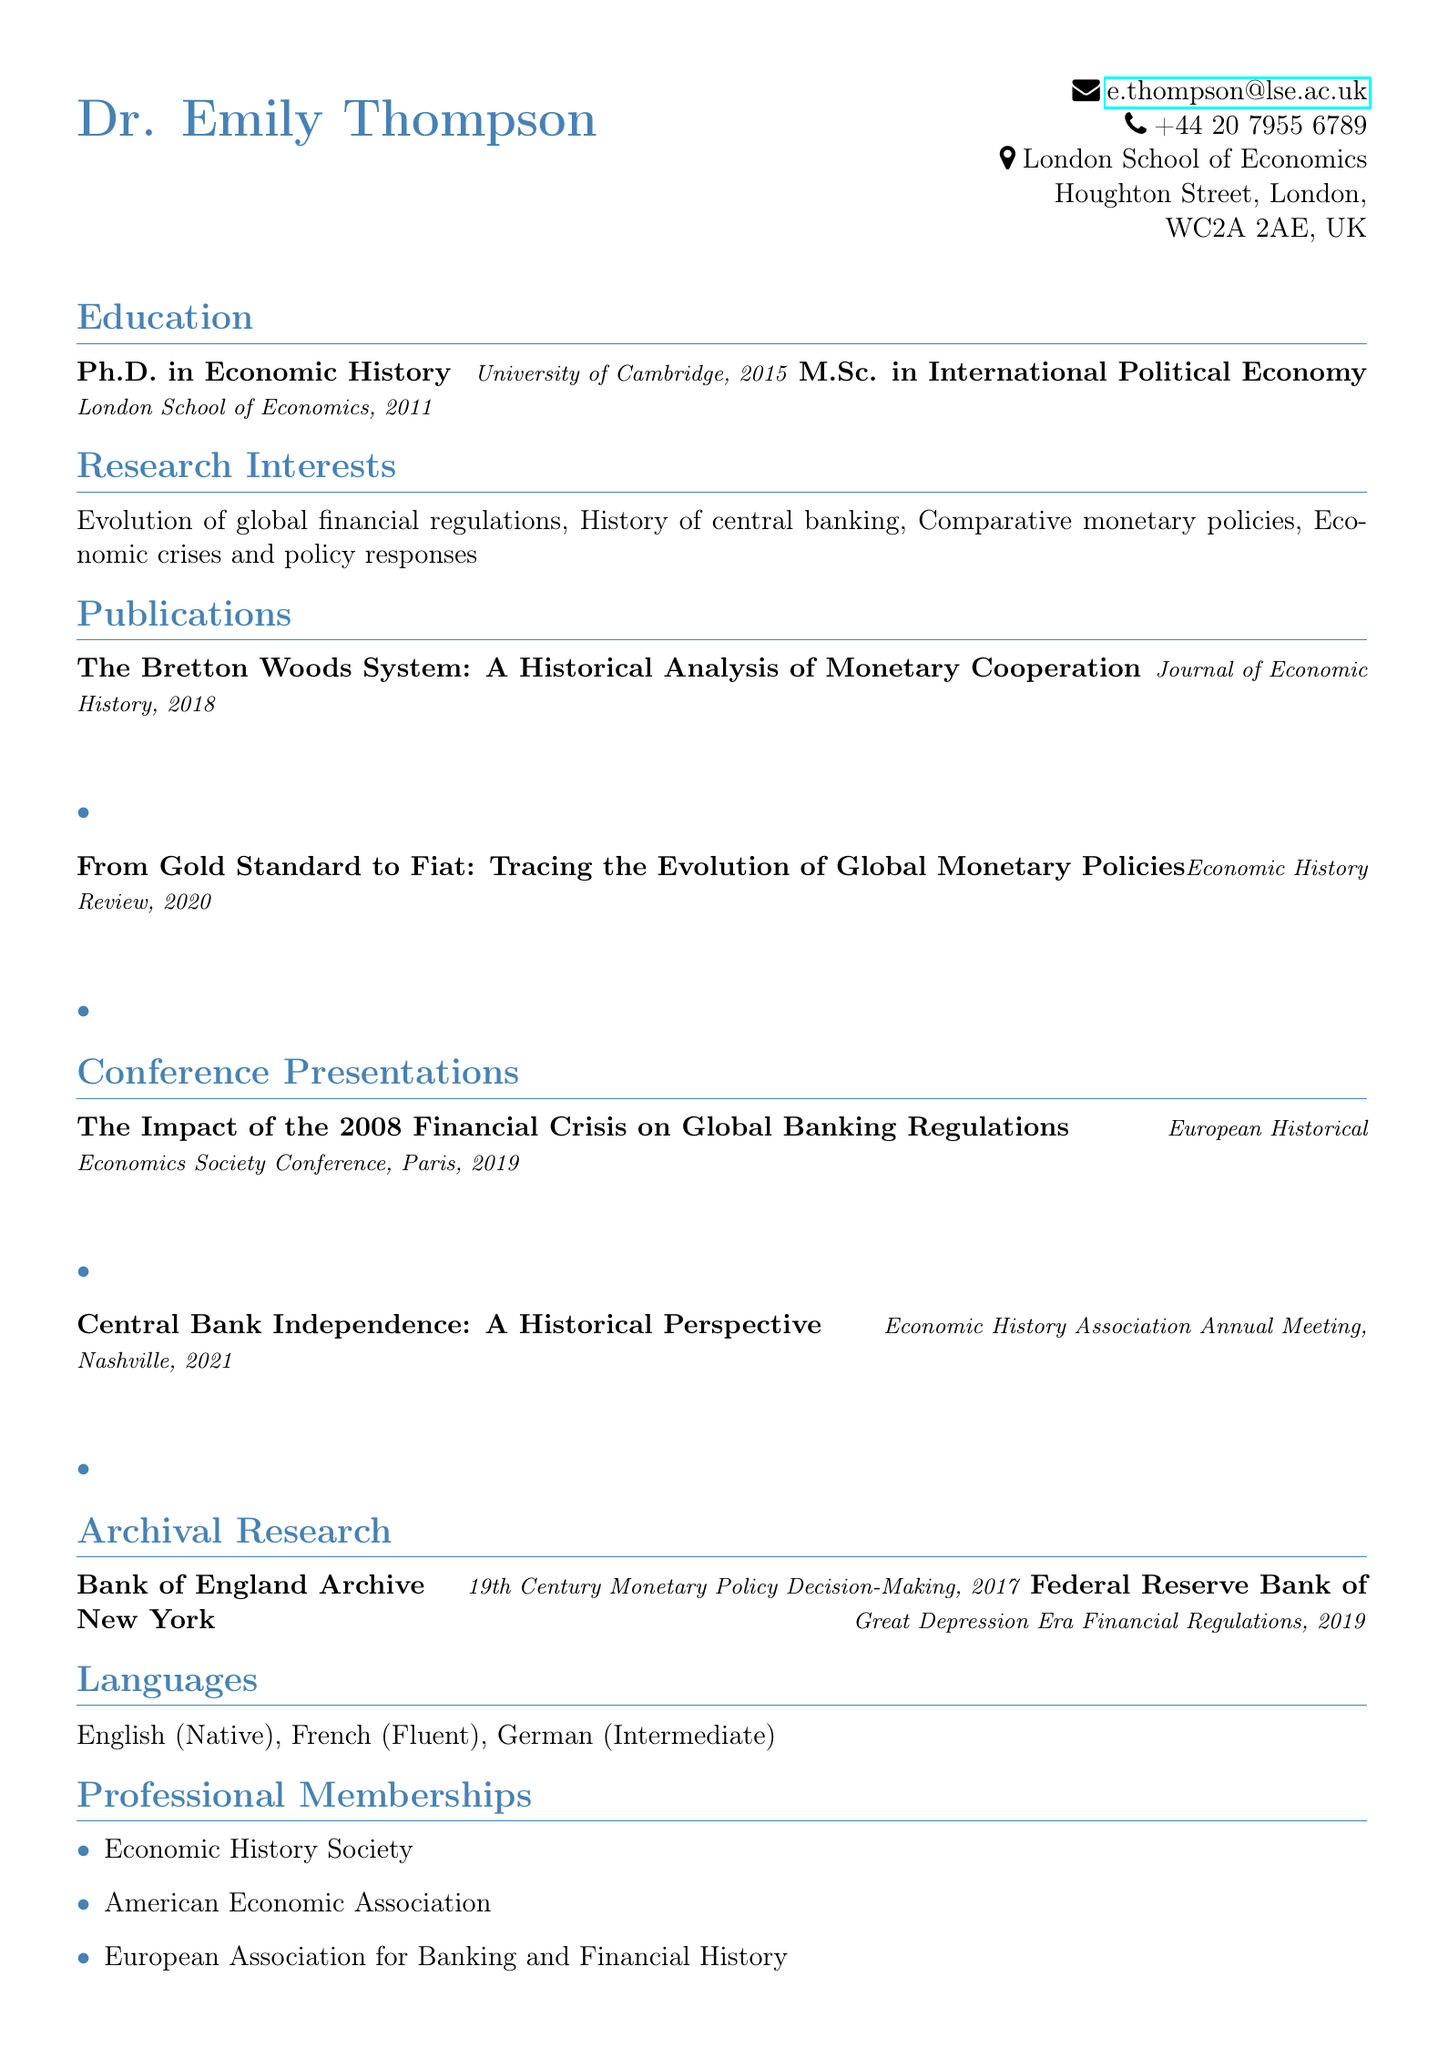What is the name of the author? The author's name is provided at the beginning of the document as Dr. Emily Thompson.
Answer: Dr. Emily Thompson In what year did Dr. Emily Thompson complete her Ph.D.? The Ph.D. is listed under the education section, specifically stating the year 2015.
Answer: 2015 What are Dr. Thompson's research interests? The research interests are listed as a series of topics relevant to her field including "Evolution of global financial regulations".
Answer: Evolution of global financial regulations Which journal published the article titled "From Gold Standard to Fiat"? The publications section states that the article was published in the Economic History Review.
Answer: Economic History Review How many languages does Dr. Emily Thompson speak? The languages section indicates she speaks three languages: English, French, and German.
Answer: Three What significant event is associated with the conference presentation in 2019? The title of the presentation relates specifically to the "2008 Financial Crisis," indicating its significance.
Answer: 2008 Financial Crisis How many professional memberships are listed? The document presents a list of three professional memberships under the professional memberships section.
Answer: Three Where did Dr. Thompson conduct archival research on financial regulations? The archival research section names the Federal Reserve Bank of New York as one of the locations.
Answer: Federal Reserve Bank of New York What type of degree did Dr. Thompson earn from the London School of Economics? The education section mentions she completed a Master of Science in International Political Economy.
Answer: M.Sc. in International Political Economy 